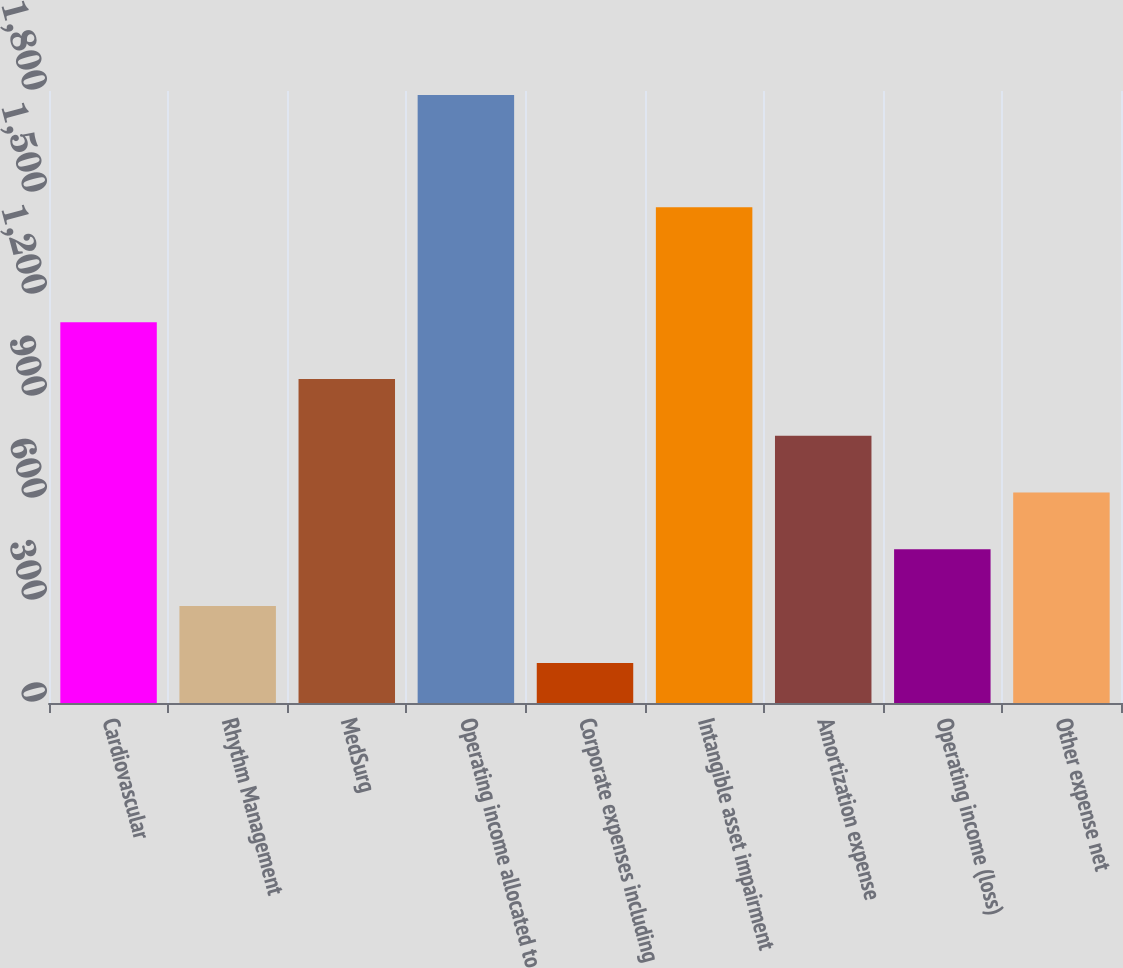Convert chart. <chart><loc_0><loc_0><loc_500><loc_500><bar_chart><fcel>Cardiovascular<fcel>Rhythm Management<fcel>MedSurg<fcel>Operating income allocated to<fcel>Corporate expenses including<fcel>Intangible asset impairment<fcel>Amortization expense<fcel>Operating income (loss)<fcel>Other expense net<nl><fcel>1120<fcel>285<fcel>953<fcel>1788<fcel>118<fcel>1458<fcel>786<fcel>452<fcel>619<nl></chart> 